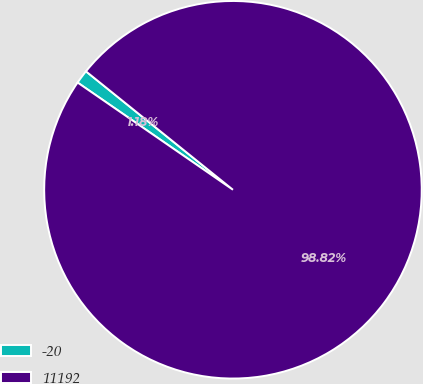Convert chart. <chart><loc_0><loc_0><loc_500><loc_500><pie_chart><fcel>-20<fcel>11192<nl><fcel>1.18%<fcel>98.82%<nl></chart> 